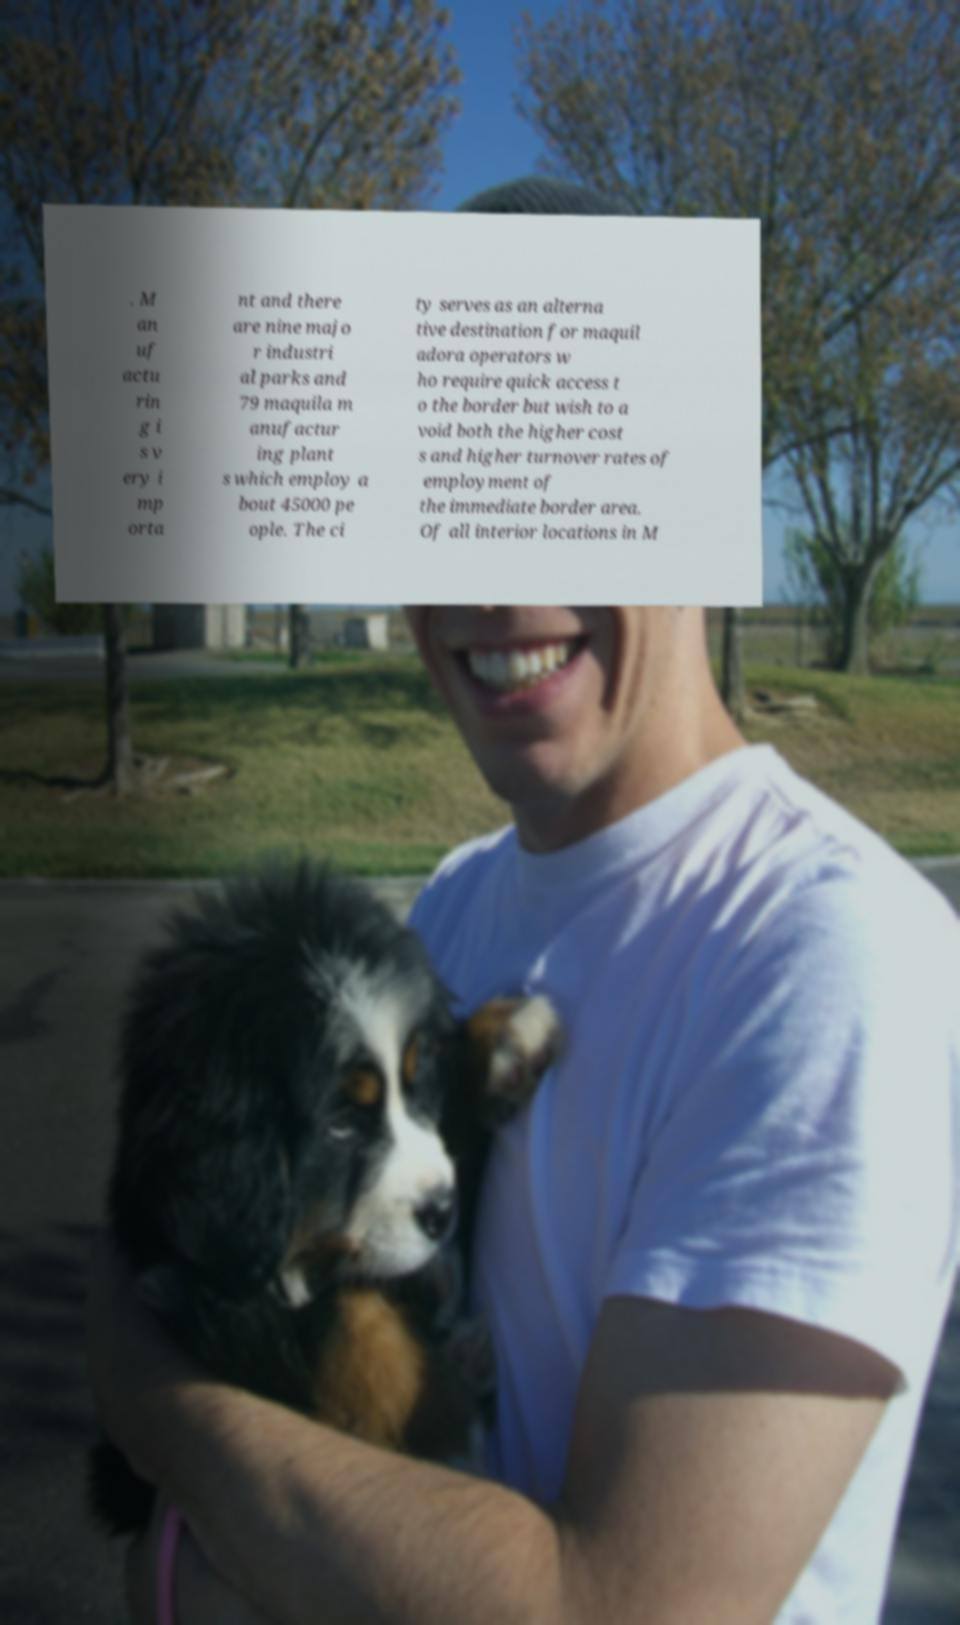What messages or text are displayed in this image? I need them in a readable, typed format. . M an uf actu rin g i s v ery i mp orta nt and there are nine majo r industri al parks and 79 maquila m anufactur ing plant s which employ a bout 45000 pe ople. The ci ty serves as an alterna tive destination for maquil adora operators w ho require quick access t o the border but wish to a void both the higher cost s and higher turnover rates of employment of the immediate border area. Of all interior locations in M 